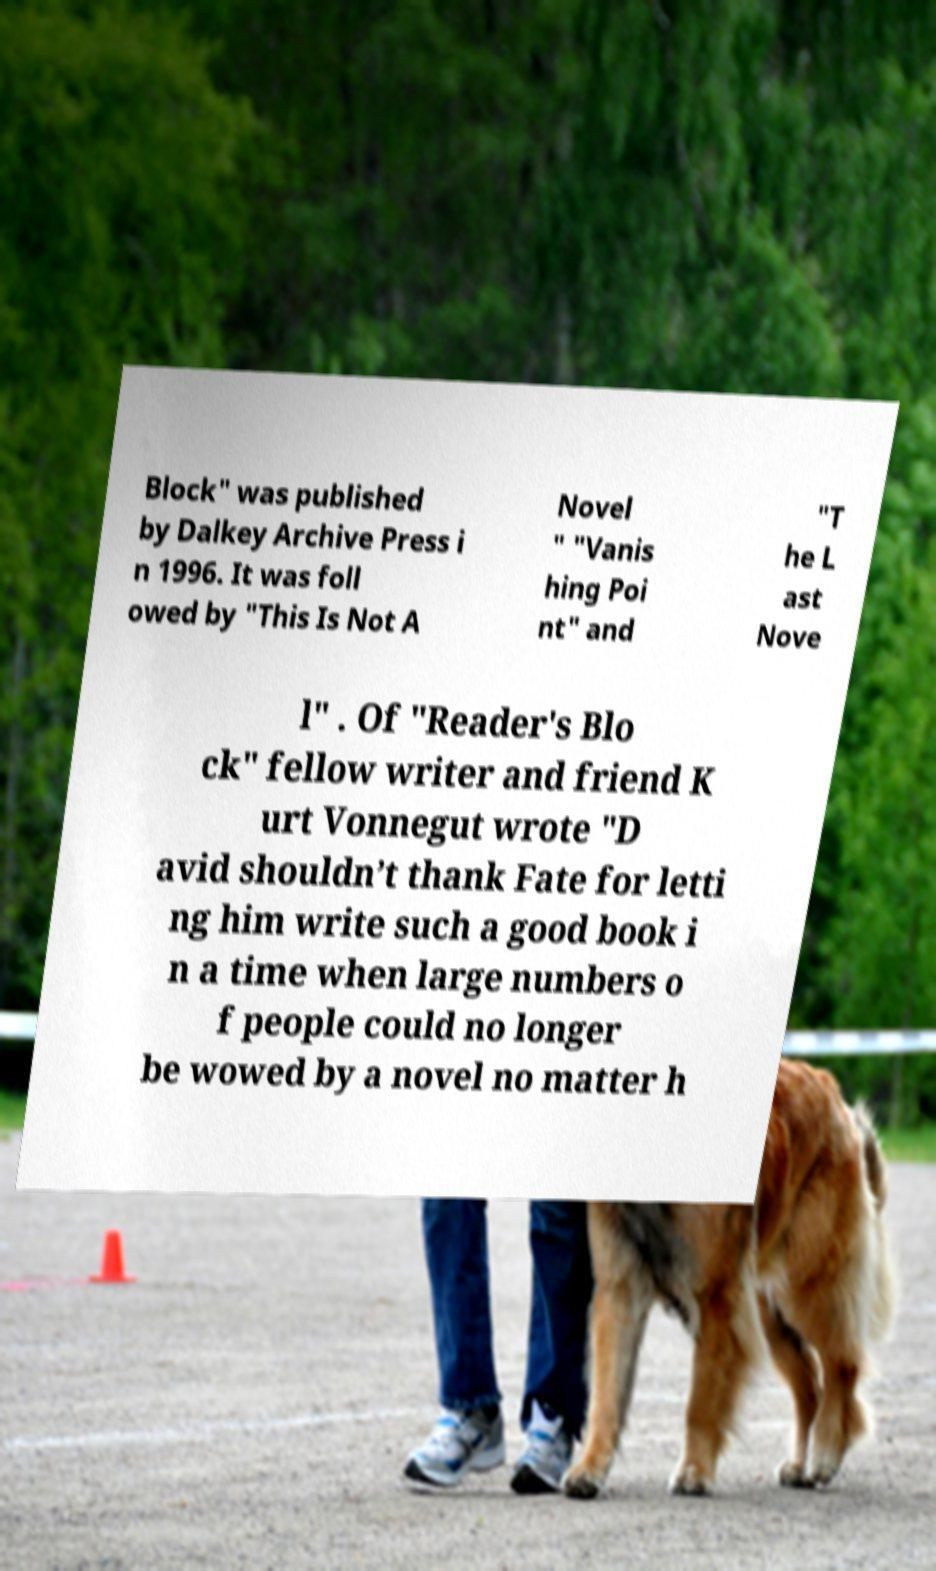Please identify and transcribe the text found in this image. Block" was published by Dalkey Archive Press i n 1996. It was foll owed by "This Is Not A Novel " "Vanis hing Poi nt" and "T he L ast Nove l" . Of "Reader's Blo ck" fellow writer and friend K urt Vonnegut wrote "D avid shouldn’t thank Fate for letti ng him write such a good book i n a time when large numbers o f people could no longer be wowed by a novel no matter h 